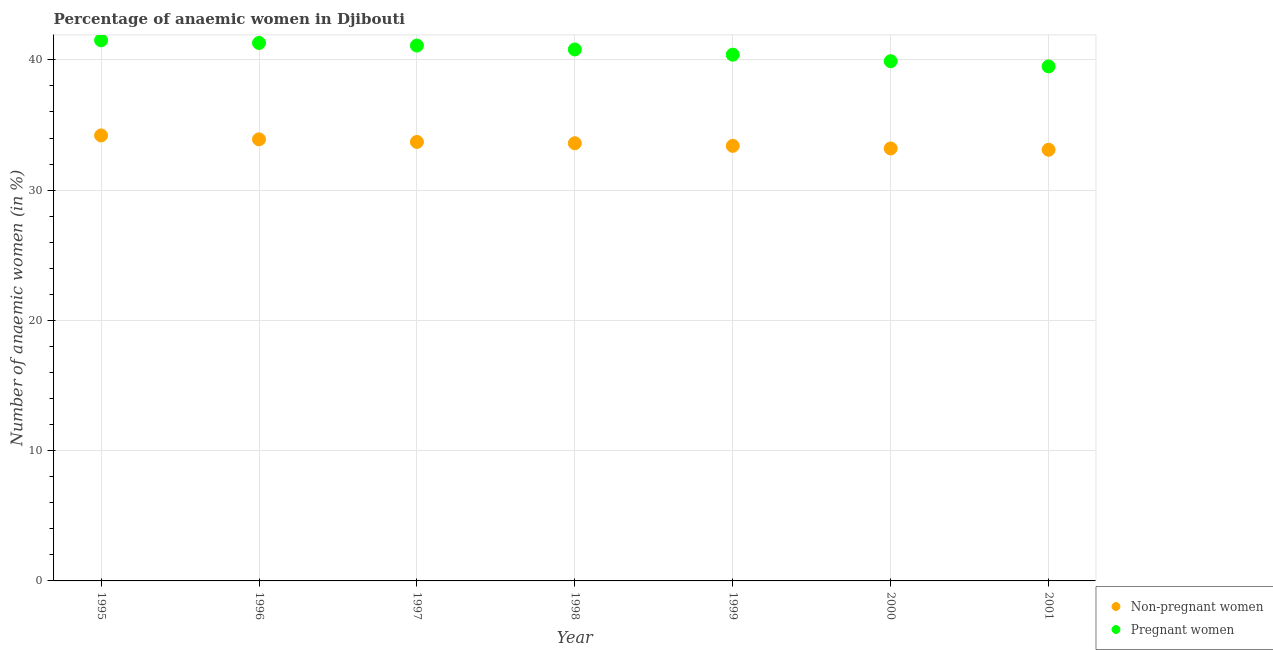How many different coloured dotlines are there?
Offer a very short reply. 2. What is the percentage of pregnant anaemic women in 1998?
Ensure brevity in your answer.  40.8. Across all years, what is the maximum percentage of non-pregnant anaemic women?
Make the answer very short. 34.2. Across all years, what is the minimum percentage of pregnant anaemic women?
Make the answer very short. 39.5. In which year was the percentage of non-pregnant anaemic women maximum?
Offer a terse response. 1995. In which year was the percentage of non-pregnant anaemic women minimum?
Give a very brief answer. 2001. What is the total percentage of non-pregnant anaemic women in the graph?
Offer a terse response. 235.1. What is the difference between the percentage of pregnant anaemic women in 1999 and that in 2001?
Your response must be concise. 0.9. What is the difference between the percentage of pregnant anaemic women in 1996 and the percentage of non-pregnant anaemic women in 2000?
Provide a succinct answer. 8.1. What is the average percentage of pregnant anaemic women per year?
Offer a very short reply. 40.64. In the year 1997, what is the difference between the percentage of pregnant anaemic women and percentage of non-pregnant anaemic women?
Ensure brevity in your answer.  7.4. In how many years, is the percentage of pregnant anaemic women greater than 8 %?
Make the answer very short. 7. What is the ratio of the percentage of non-pregnant anaemic women in 1995 to that in 1998?
Your response must be concise. 1.02. Is the percentage of non-pregnant anaemic women in 1995 less than that in 2000?
Keep it short and to the point. No. Is the difference between the percentage of pregnant anaemic women in 1995 and 1997 greater than the difference between the percentage of non-pregnant anaemic women in 1995 and 1997?
Your answer should be compact. No. What is the difference between the highest and the second highest percentage of non-pregnant anaemic women?
Provide a succinct answer. 0.3. What is the difference between the highest and the lowest percentage of non-pregnant anaemic women?
Provide a succinct answer. 1.1. Is the sum of the percentage of non-pregnant anaemic women in 2000 and 2001 greater than the maximum percentage of pregnant anaemic women across all years?
Your answer should be very brief. Yes. Does the percentage of pregnant anaemic women monotonically increase over the years?
Offer a very short reply. No. How many years are there in the graph?
Provide a short and direct response. 7. Are the values on the major ticks of Y-axis written in scientific E-notation?
Provide a short and direct response. No. Does the graph contain grids?
Give a very brief answer. Yes. How many legend labels are there?
Provide a short and direct response. 2. How are the legend labels stacked?
Your response must be concise. Vertical. What is the title of the graph?
Make the answer very short. Percentage of anaemic women in Djibouti. Does "Resident" appear as one of the legend labels in the graph?
Make the answer very short. No. What is the label or title of the X-axis?
Offer a terse response. Year. What is the label or title of the Y-axis?
Give a very brief answer. Number of anaemic women (in %). What is the Number of anaemic women (in %) in Non-pregnant women in 1995?
Offer a terse response. 34.2. What is the Number of anaemic women (in %) in Pregnant women in 1995?
Keep it short and to the point. 41.5. What is the Number of anaemic women (in %) of Non-pregnant women in 1996?
Offer a very short reply. 33.9. What is the Number of anaemic women (in %) of Pregnant women in 1996?
Your response must be concise. 41.3. What is the Number of anaemic women (in %) of Non-pregnant women in 1997?
Your answer should be compact. 33.7. What is the Number of anaemic women (in %) of Pregnant women in 1997?
Your response must be concise. 41.1. What is the Number of anaemic women (in %) in Non-pregnant women in 1998?
Keep it short and to the point. 33.6. What is the Number of anaemic women (in %) in Pregnant women in 1998?
Your response must be concise. 40.8. What is the Number of anaemic women (in %) of Non-pregnant women in 1999?
Offer a terse response. 33.4. What is the Number of anaemic women (in %) of Pregnant women in 1999?
Your answer should be very brief. 40.4. What is the Number of anaemic women (in %) of Non-pregnant women in 2000?
Your response must be concise. 33.2. What is the Number of anaemic women (in %) of Pregnant women in 2000?
Provide a short and direct response. 39.9. What is the Number of anaemic women (in %) of Non-pregnant women in 2001?
Give a very brief answer. 33.1. What is the Number of anaemic women (in %) of Pregnant women in 2001?
Provide a succinct answer. 39.5. Across all years, what is the maximum Number of anaemic women (in %) of Non-pregnant women?
Offer a terse response. 34.2. Across all years, what is the maximum Number of anaemic women (in %) in Pregnant women?
Make the answer very short. 41.5. Across all years, what is the minimum Number of anaemic women (in %) in Non-pregnant women?
Provide a short and direct response. 33.1. Across all years, what is the minimum Number of anaemic women (in %) of Pregnant women?
Offer a terse response. 39.5. What is the total Number of anaemic women (in %) of Non-pregnant women in the graph?
Ensure brevity in your answer.  235.1. What is the total Number of anaemic women (in %) of Pregnant women in the graph?
Keep it short and to the point. 284.5. What is the difference between the Number of anaemic women (in %) in Non-pregnant women in 1995 and that in 1996?
Offer a very short reply. 0.3. What is the difference between the Number of anaemic women (in %) of Pregnant women in 1995 and that in 1996?
Your answer should be very brief. 0.2. What is the difference between the Number of anaemic women (in %) of Pregnant women in 1995 and that in 1998?
Offer a very short reply. 0.7. What is the difference between the Number of anaemic women (in %) in Non-pregnant women in 1995 and that in 1999?
Your response must be concise. 0.8. What is the difference between the Number of anaemic women (in %) in Pregnant women in 1995 and that in 1999?
Provide a succinct answer. 1.1. What is the difference between the Number of anaemic women (in %) in Pregnant women in 1995 and that in 2001?
Provide a succinct answer. 2. What is the difference between the Number of anaemic women (in %) in Non-pregnant women in 1996 and that in 1997?
Keep it short and to the point. 0.2. What is the difference between the Number of anaemic women (in %) of Pregnant women in 1996 and that in 1997?
Provide a succinct answer. 0.2. What is the difference between the Number of anaemic women (in %) in Non-pregnant women in 1996 and that in 1999?
Keep it short and to the point. 0.5. What is the difference between the Number of anaemic women (in %) in Non-pregnant women in 1996 and that in 2001?
Provide a short and direct response. 0.8. What is the difference between the Number of anaemic women (in %) in Pregnant women in 1996 and that in 2001?
Provide a short and direct response. 1.8. What is the difference between the Number of anaemic women (in %) of Non-pregnant women in 1997 and that in 2001?
Make the answer very short. 0.6. What is the difference between the Number of anaemic women (in %) of Pregnant women in 1997 and that in 2001?
Your answer should be compact. 1.6. What is the difference between the Number of anaemic women (in %) of Non-pregnant women in 1998 and that in 1999?
Give a very brief answer. 0.2. What is the difference between the Number of anaemic women (in %) in Pregnant women in 1998 and that in 1999?
Give a very brief answer. 0.4. What is the difference between the Number of anaemic women (in %) of Pregnant women in 1998 and that in 2000?
Your response must be concise. 0.9. What is the difference between the Number of anaemic women (in %) in Non-pregnant women in 1998 and that in 2001?
Provide a short and direct response. 0.5. What is the difference between the Number of anaemic women (in %) in Pregnant women in 1998 and that in 2001?
Offer a terse response. 1.3. What is the difference between the Number of anaemic women (in %) of Pregnant women in 1999 and that in 2001?
Your answer should be compact. 0.9. What is the difference between the Number of anaemic women (in %) of Non-pregnant women in 2000 and that in 2001?
Provide a succinct answer. 0.1. What is the difference between the Number of anaemic women (in %) in Non-pregnant women in 1995 and the Number of anaemic women (in %) in Pregnant women in 1996?
Ensure brevity in your answer.  -7.1. What is the difference between the Number of anaemic women (in %) of Non-pregnant women in 1995 and the Number of anaemic women (in %) of Pregnant women in 1997?
Provide a succinct answer. -6.9. What is the difference between the Number of anaemic women (in %) of Non-pregnant women in 1995 and the Number of anaemic women (in %) of Pregnant women in 1999?
Provide a short and direct response. -6.2. What is the difference between the Number of anaemic women (in %) in Non-pregnant women in 1995 and the Number of anaemic women (in %) in Pregnant women in 2000?
Provide a short and direct response. -5.7. What is the difference between the Number of anaemic women (in %) in Non-pregnant women in 1995 and the Number of anaemic women (in %) in Pregnant women in 2001?
Your answer should be compact. -5.3. What is the difference between the Number of anaemic women (in %) of Non-pregnant women in 1996 and the Number of anaemic women (in %) of Pregnant women in 1998?
Provide a succinct answer. -6.9. What is the difference between the Number of anaemic women (in %) in Non-pregnant women in 1996 and the Number of anaemic women (in %) in Pregnant women in 2000?
Give a very brief answer. -6. What is the difference between the Number of anaemic women (in %) in Non-pregnant women in 1997 and the Number of anaemic women (in %) in Pregnant women in 2000?
Provide a succinct answer. -6.2. What is the difference between the Number of anaemic women (in %) of Non-pregnant women in 1998 and the Number of anaemic women (in %) of Pregnant women in 1999?
Your response must be concise. -6.8. What is the difference between the Number of anaemic women (in %) of Non-pregnant women in 1998 and the Number of anaemic women (in %) of Pregnant women in 2000?
Give a very brief answer. -6.3. What is the average Number of anaemic women (in %) of Non-pregnant women per year?
Your response must be concise. 33.59. What is the average Number of anaemic women (in %) in Pregnant women per year?
Offer a very short reply. 40.64. In the year 1999, what is the difference between the Number of anaemic women (in %) of Non-pregnant women and Number of anaemic women (in %) of Pregnant women?
Give a very brief answer. -7. What is the ratio of the Number of anaemic women (in %) of Non-pregnant women in 1995 to that in 1996?
Give a very brief answer. 1.01. What is the ratio of the Number of anaemic women (in %) of Pregnant women in 1995 to that in 1996?
Your answer should be compact. 1. What is the ratio of the Number of anaemic women (in %) in Non-pregnant women in 1995 to that in 1997?
Your answer should be very brief. 1.01. What is the ratio of the Number of anaemic women (in %) of Pregnant women in 1995 to that in 1997?
Offer a very short reply. 1.01. What is the ratio of the Number of anaemic women (in %) in Non-pregnant women in 1995 to that in 1998?
Offer a terse response. 1.02. What is the ratio of the Number of anaemic women (in %) in Pregnant women in 1995 to that in 1998?
Keep it short and to the point. 1.02. What is the ratio of the Number of anaemic women (in %) of Non-pregnant women in 1995 to that in 1999?
Give a very brief answer. 1.02. What is the ratio of the Number of anaemic women (in %) of Pregnant women in 1995 to that in 1999?
Your answer should be very brief. 1.03. What is the ratio of the Number of anaemic women (in %) in Non-pregnant women in 1995 to that in 2000?
Your answer should be very brief. 1.03. What is the ratio of the Number of anaemic women (in %) in Pregnant women in 1995 to that in 2000?
Give a very brief answer. 1.04. What is the ratio of the Number of anaemic women (in %) of Non-pregnant women in 1995 to that in 2001?
Your answer should be compact. 1.03. What is the ratio of the Number of anaemic women (in %) of Pregnant women in 1995 to that in 2001?
Your answer should be very brief. 1.05. What is the ratio of the Number of anaemic women (in %) of Non-pregnant women in 1996 to that in 1997?
Offer a very short reply. 1.01. What is the ratio of the Number of anaemic women (in %) in Non-pregnant women in 1996 to that in 1998?
Keep it short and to the point. 1.01. What is the ratio of the Number of anaemic women (in %) of Pregnant women in 1996 to that in 1998?
Offer a very short reply. 1.01. What is the ratio of the Number of anaemic women (in %) of Non-pregnant women in 1996 to that in 1999?
Offer a terse response. 1.01. What is the ratio of the Number of anaemic women (in %) in Pregnant women in 1996 to that in 1999?
Keep it short and to the point. 1.02. What is the ratio of the Number of anaemic women (in %) in Non-pregnant women in 1996 to that in 2000?
Give a very brief answer. 1.02. What is the ratio of the Number of anaemic women (in %) of Pregnant women in 1996 to that in 2000?
Provide a succinct answer. 1.04. What is the ratio of the Number of anaemic women (in %) of Non-pregnant women in 1996 to that in 2001?
Give a very brief answer. 1.02. What is the ratio of the Number of anaemic women (in %) of Pregnant women in 1996 to that in 2001?
Make the answer very short. 1.05. What is the ratio of the Number of anaemic women (in %) of Non-pregnant women in 1997 to that in 1998?
Your answer should be very brief. 1. What is the ratio of the Number of anaemic women (in %) in Pregnant women in 1997 to that in 1998?
Make the answer very short. 1.01. What is the ratio of the Number of anaemic women (in %) of Pregnant women in 1997 to that in 1999?
Your answer should be compact. 1.02. What is the ratio of the Number of anaemic women (in %) in Non-pregnant women in 1997 to that in 2000?
Ensure brevity in your answer.  1.02. What is the ratio of the Number of anaemic women (in %) in Pregnant women in 1997 to that in 2000?
Ensure brevity in your answer.  1.03. What is the ratio of the Number of anaemic women (in %) of Non-pregnant women in 1997 to that in 2001?
Your answer should be compact. 1.02. What is the ratio of the Number of anaemic women (in %) of Pregnant women in 1997 to that in 2001?
Offer a very short reply. 1.04. What is the ratio of the Number of anaemic women (in %) of Pregnant women in 1998 to that in 1999?
Make the answer very short. 1.01. What is the ratio of the Number of anaemic women (in %) in Pregnant women in 1998 to that in 2000?
Provide a short and direct response. 1.02. What is the ratio of the Number of anaemic women (in %) of Non-pregnant women in 1998 to that in 2001?
Ensure brevity in your answer.  1.02. What is the ratio of the Number of anaemic women (in %) in Pregnant women in 1998 to that in 2001?
Keep it short and to the point. 1.03. What is the ratio of the Number of anaemic women (in %) of Pregnant women in 1999 to that in 2000?
Your answer should be very brief. 1.01. What is the ratio of the Number of anaemic women (in %) of Non-pregnant women in 1999 to that in 2001?
Provide a succinct answer. 1.01. What is the ratio of the Number of anaemic women (in %) of Pregnant women in 1999 to that in 2001?
Your answer should be very brief. 1.02. What is the difference between the highest and the second highest Number of anaemic women (in %) of Non-pregnant women?
Provide a succinct answer. 0.3. What is the difference between the highest and the second highest Number of anaemic women (in %) in Pregnant women?
Give a very brief answer. 0.2. What is the difference between the highest and the lowest Number of anaemic women (in %) of Pregnant women?
Your answer should be very brief. 2. 